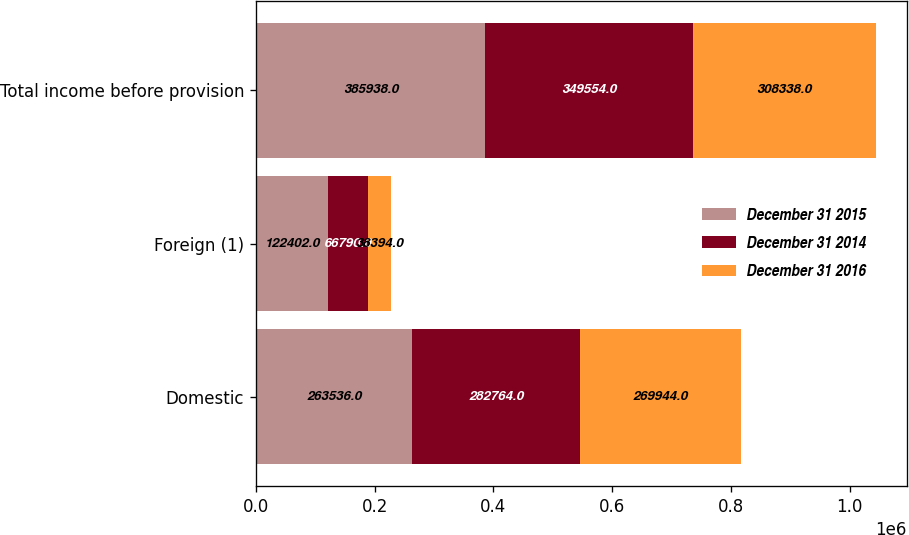Convert chart to OTSL. <chart><loc_0><loc_0><loc_500><loc_500><stacked_bar_chart><ecel><fcel>Domestic<fcel>Foreign (1)<fcel>Total income before provision<nl><fcel>December 31 2015<fcel>263536<fcel>122402<fcel>385938<nl><fcel>December 31 2014<fcel>282764<fcel>66790<fcel>349554<nl><fcel>December 31 2016<fcel>269944<fcel>38394<fcel>308338<nl></chart> 